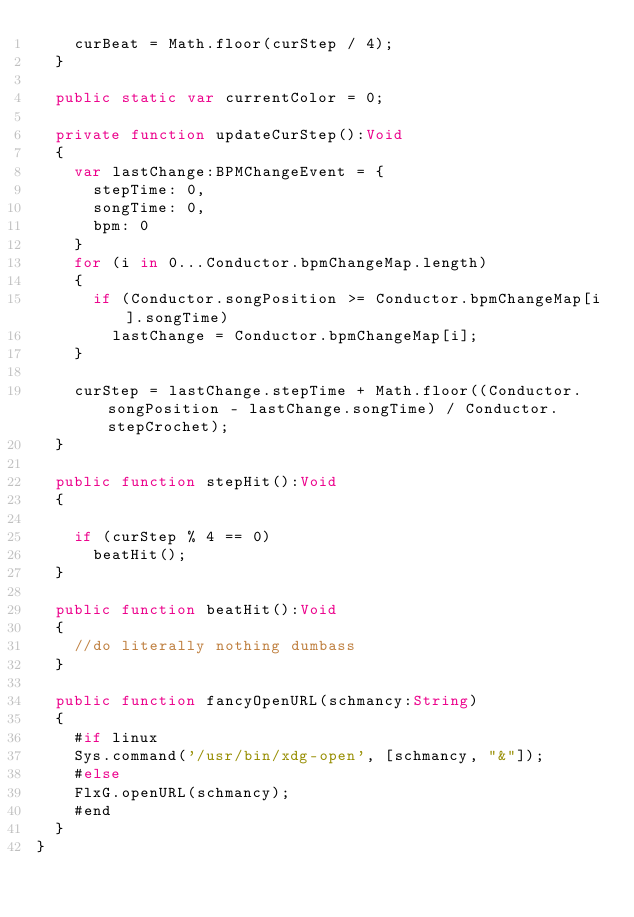<code> <loc_0><loc_0><loc_500><loc_500><_Haxe_>		curBeat = Math.floor(curStep / 4);
	}

	public static var currentColor = 0;

	private function updateCurStep():Void
	{
		var lastChange:BPMChangeEvent = {
			stepTime: 0,
			songTime: 0,
			bpm: 0
		}
		for (i in 0...Conductor.bpmChangeMap.length)
		{
			if (Conductor.songPosition >= Conductor.bpmChangeMap[i].songTime)
				lastChange = Conductor.bpmChangeMap[i];
		}

		curStep = lastChange.stepTime + Math.floor((Conductor.songPosition - lastChange.songTime) / Conductor.stepCrochet);
	}

	public function stepHit():Void
	{

		if (curStep % 4 == 0)
			beatHit();
	}

	public function beatHit():Void
	{
		//do literally nothing dumbass
	}
	
	public function fancyOpenURL(schmancy:String)
	{
		#if linux
		Sys.command('/usr/bin/xdg-open', [schmancy, "&"]);
		#else
		FlxG.openURL(schmancy);
		#end
	}
}
</code> 